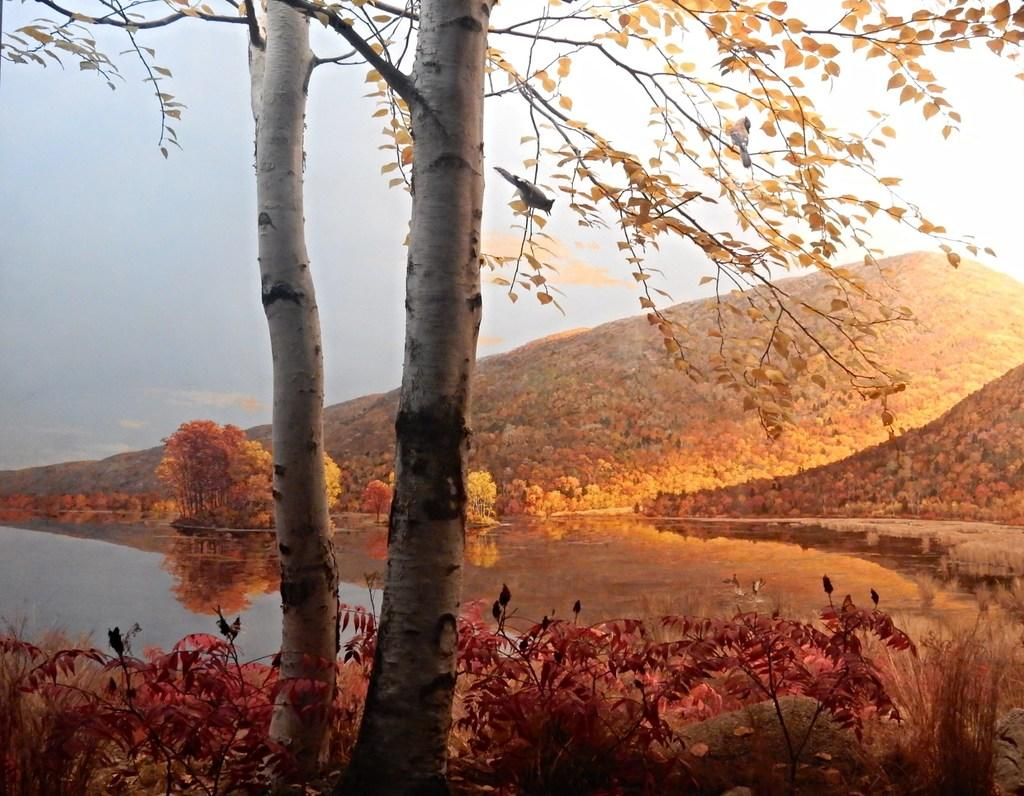What type of geographical feature is the main subject of the image? There is a mountain in the image. What other natural elements can be seen in the image? There are many trees and plants in the image. Is there any body of water visible in the image? Yes, there is a river in the image. What type of error can be seen in the image? There is no error present in the image; it is a natural scene featuring a mountain, trees, plants, and a river. Can you describe the authority figure in the image? There is no authority figure present in the image; it is a natural scene without any human or man-made elements. 